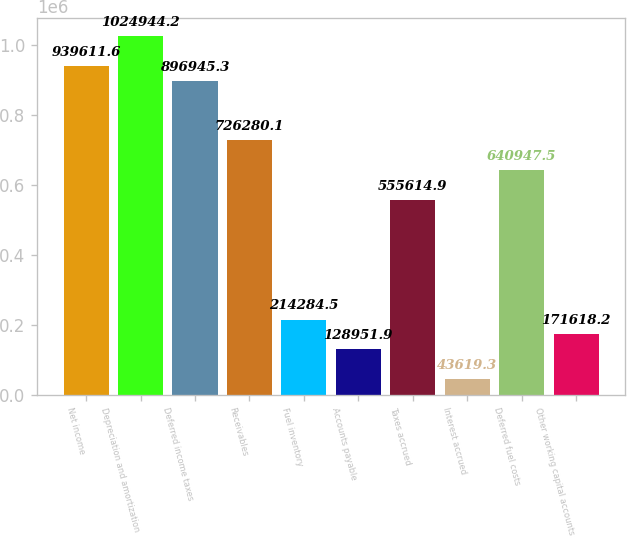Convert chart. <chart><loc_0><loc_0><loc_500><loc_500><bar_chart><fcel>Net income<fcel>Depreciation and amortization<fcel>Deferred income taxes<fcel>Receivables<fcel>Fuel inventory<fcel>Accounts payable<fcel>Taxes accrued<fcel>Interest accrued<fcel>Deferred fuel costs<fcel>Other working capital accounts<nl><fcel>939612<fcel>1.02494e+06<fcel>896945<fcel>726280<fcel>214284<fcel>128952<fcel>555615<fcel>43619.3<fcel>640948<fcel>171618<nl></chart> 